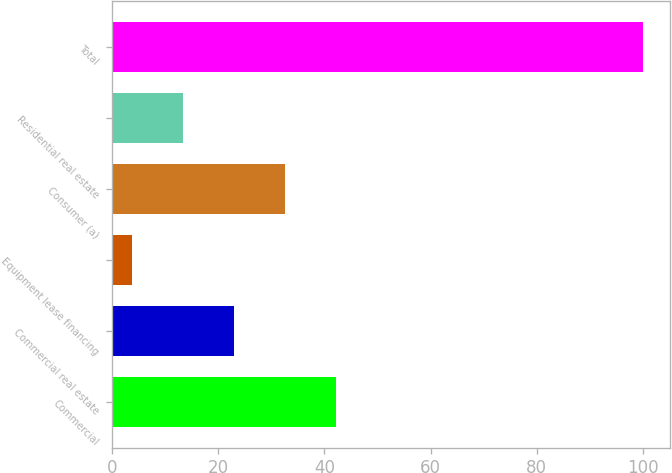Convert chart. <chart><loc_0><loc_0><loc_500><loc_500><bar_chart><fcel>Commercial<fcel>Commercial real estate<fcel>Equipment lease financing<fcel>Consumer (a)<fcel>Residential real estate<fcel>Total<nl><fcel>42.22<fcel>22.96<fcel>3.7<fcel>32.59<fcel>13.33<fcel>100<nl></chart> 